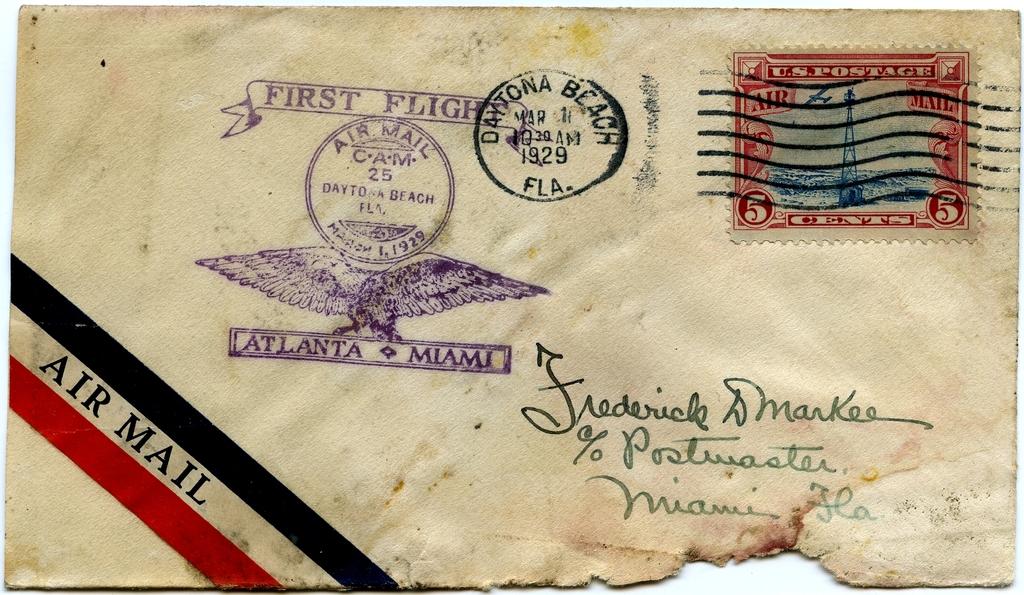What type of mail is this?
Give a very brief answer. Air mail. What year was this letter mailed?
Provide a short and direct response. 1929. 